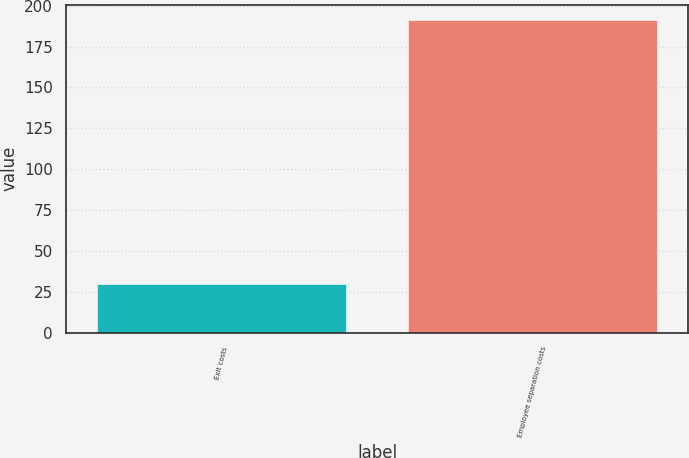Convert chart to OTSL. <chart><loc_0><loc_0><loc_500><loc_500><bar_chart><fcel>Exit costs<fcel>Employee separation costs<nl><fcel>30<fcel>191<nl></chart> 